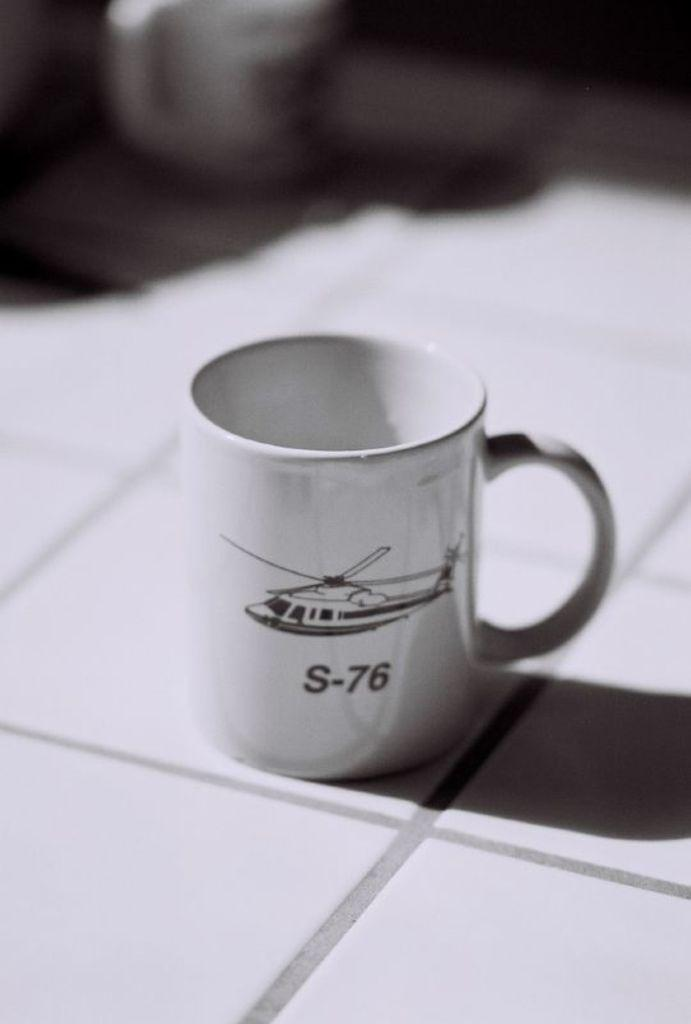Provide a one-sentence caption for the provided image. A mug with a helicopter and S-76 below it sits on a tiled surface. 